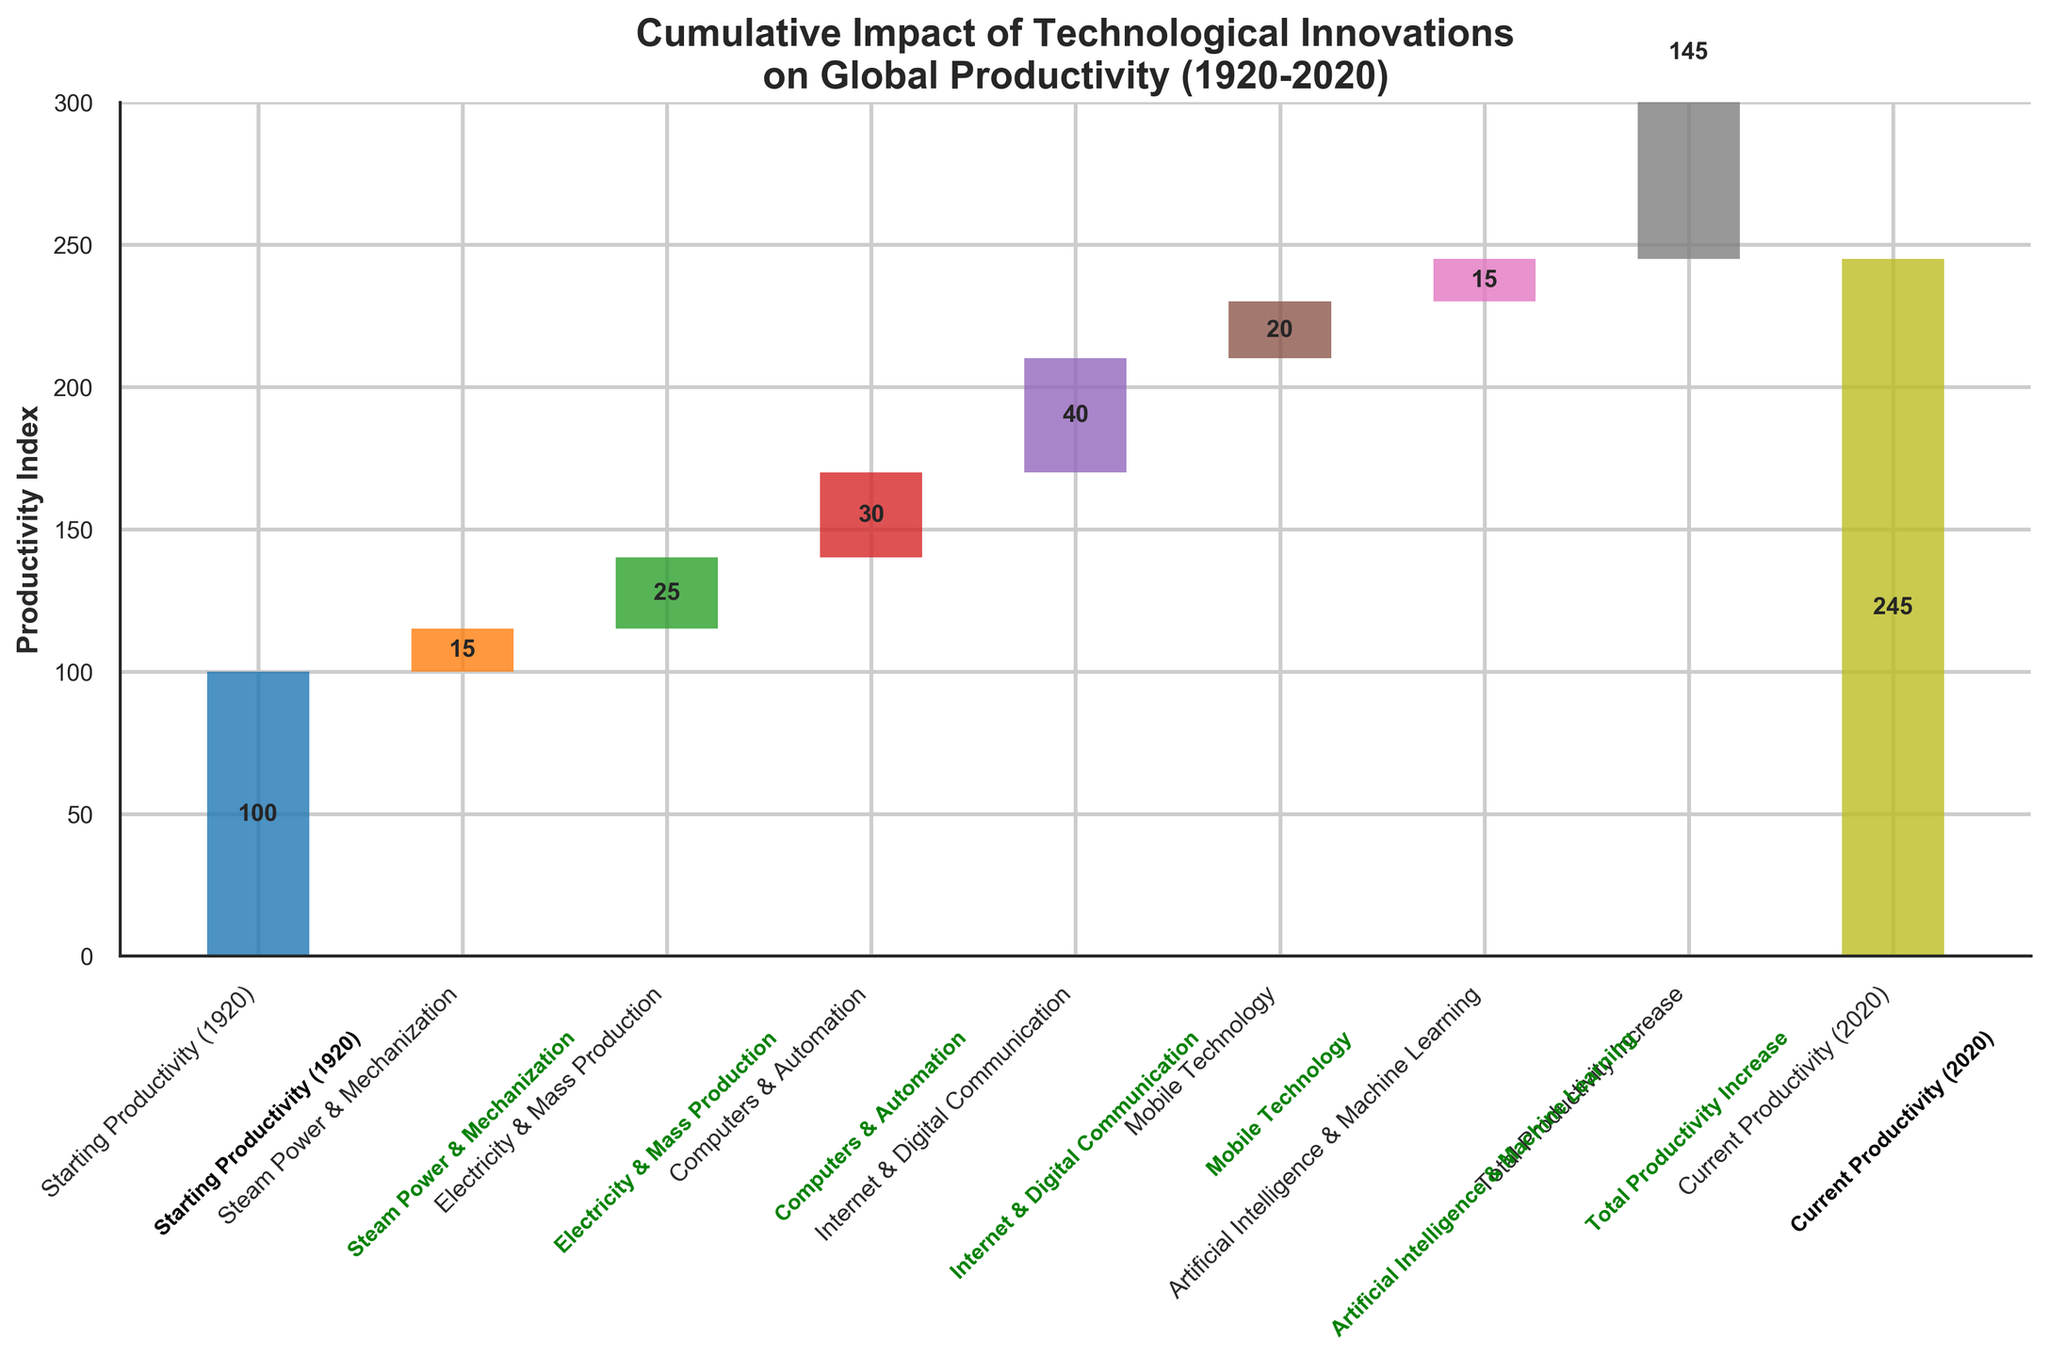What is the title of the chart? The title of the chart is typically written at the top and it summarizes the content of the figure. Here the title is "Cumulative Impact of Technological Innovations on Global Productivity (1920-2020)" as displayed at the top of the figure.
Answer: Cumulative Impact of Technological Innovations on Global Productivity (1920-2020) What is the starting productivity value in 1920? The starting productivity value is marked at the base of the first bar on the chart, labeled "Starting Productivity (1920)". The text on the bar shows the value of 100.
Answer: 100 Which technological innovation category contributed the highest increase in productivity? To identify this, one needs to compare the values associated with each category. "Internet & Digital Communication" has the highest increase with a value of 40.
Answer: Internet & Digital Communication What is the total productivity increase from 1920 to 2020? The "Total Productivity Increase" bar at the end of the chart shows the cumulative increase from all technological innovations combined. The value is marked as 145, indicating the overall productivity increase.
Answer: 145 How much did "Steam Power & Mechanization" contribute to the productivity increase? This can be seen by looking at the bar labeled "Steam Power & Mechanization". The value next to it is 15.
Answer: 15 What is the current productivity value in 2020? The final bar of the chart labeled “Current Productivity (2020)” displays the current productivity value, which is 245 as shown on the bar.
Answer: 245 How much more did "Computers & Automation" contribute compared to "Steam Power & Mechanization"? The productivity increase for "Computers & Automation" is 30, and for "Steam Power & Mechanization" it is 15. The difference is 30 - 15 = 15.
Answer: 15 What is the average productivity increase per category (excluding the starting and current productivity)? To find the average, sum the values of the categories excluding the starting and current productivity (15 + 25 + 30 + 40 + 20 + 15) = 145, then divide by the number of categories (6). So, 145/6 ≈ 24.17.
Answer: 24.17 Which two technology categories had equal contributions to productivity increase? Comparing all values, "Steam Power & Mechanization" and "Artificial Intelligence & Machine Learning" both contributed 15 to the productivity increase.
Answer: Steam Power & Mechanization and Artificial Intelligence & Machine Learning What is the cumulative productivity value at the introduction of "Mobile Technology"? The cumulative value before "Mobile Technology" is achieved by summing the starting value and all previous contributions: 100 (starting) + 15 (Steam Power & Mechanization) + 25 (Electricity & Mass Production) + 30 (Computers & Automation) + 40 (Internet & Digital Communication) = 210.
Answer: 210 